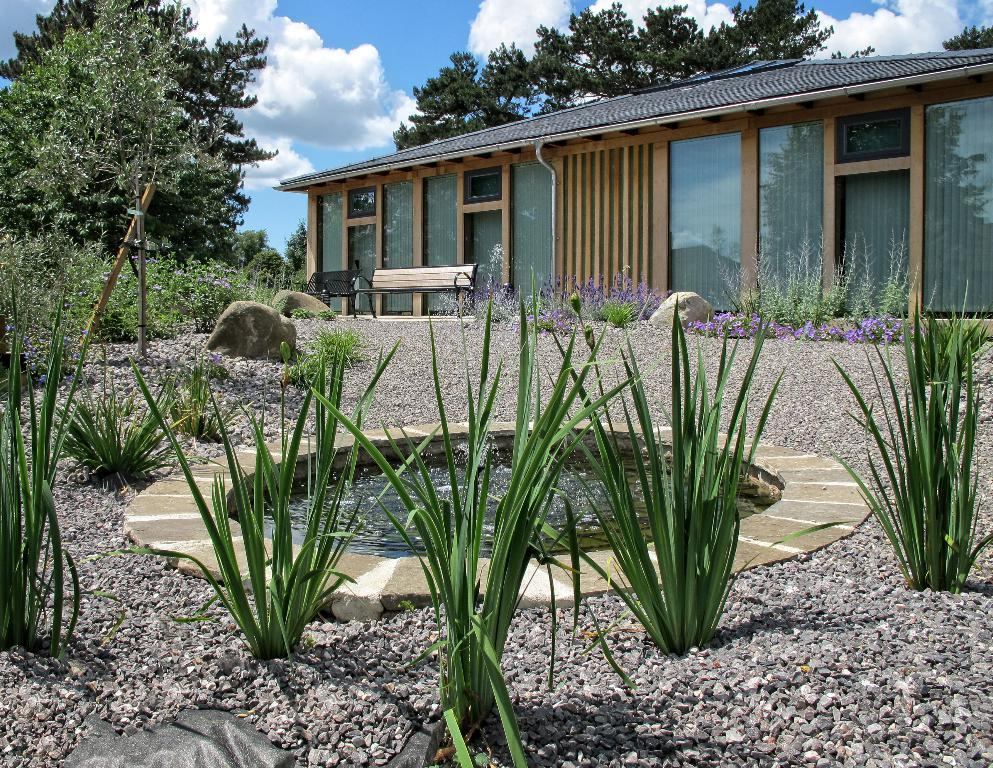What type of structure is visible in the picture? There is a house in the picture. What other natural elements can be seen in the picture? There are plants, rocks, trees, and a water pond in the picture. What type of seating is available in the picture? There is a bench in the picture. How would you describe the sky in the picture? The sky is blue and cloudy in the picture. What type of work is being done on the base of the house in the picture? There is no indication of any work being done on the base of the house in the picture. Can you hear the sound of the water pond in the picture? The image is silent, so it is not possible to hear the sound of the water pond. 